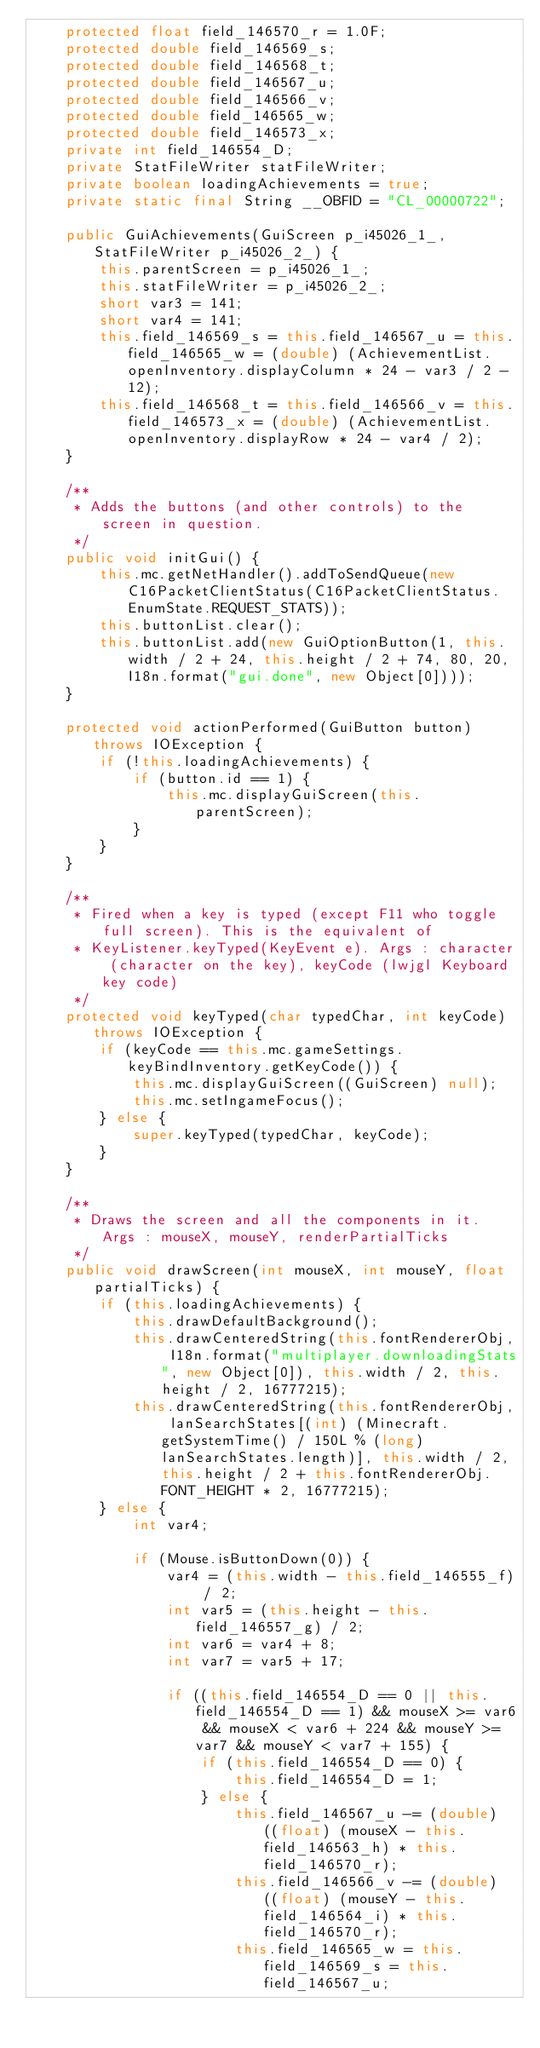Convert code to text. <code><loc_0><loc_0><loc_500><loc_500><_Java_>    protected float field_146570_r = 1.0F;
    protected double field_146569_s;
    protected double field_146568_t;
    protected double field_146567_u;
    protected double field_146566_v;
    protected double field_146565_w;
    protected double field_146573_x;
    private int field_146554_D;
    private StatFileWriter statFileWriter;
    private boolean loadingAchievements = true;
    private static final String __OBFID = "CL_00000722";

    public GuiAchievements(GuiScreen p_i45026_1_, StatFileWriter p_i45026_2_) {
        this.parentScreen = p_i45026_1_;
        this.statFileWriter = p_i45026_2_;
        short var3 = 141;
        short var4 = 141;
        this.field_146569_s = this.field_146567_u = this.field_146565_w = (double) (AchievementList.openInventory.displayColumn * 24 - var3 / 2 - 12);
        this.field_146568_t = this.field_146566_v = this.field_146573_x = (double) (AchievementList.openInventory.displayRow * 24 - var4 / 2);
    }

    /**
     * Adds the buttons (and other controls) to the screen in question.
     */
    public void initGui() {
        this.mc.getNetHandler().addToSendQueue(new C16PacketClientStatus(C16PacketClientStatus.EnumState.REQUEST_STATS));
        this.buttonList.clear();
        this.buttonList.add(new GuiOptionButton(1, this.width / 2 + 24, this.height / 2 + 74, 80, 20, I18n.format("gui.done", new Object[0])));
    }

    protected void actionPerformed(GuiButton button) throws IOException {
        if (!this.loadingAchievements) {
            if (button.id == 1) {
                this.mc.displayGuiScreen(this.parentScreen);
            }
        }
    }

    /**
     * Fired when a key is typed (except F11 who toggle full screen). This is the equivalent of
     * KeyListener.keyTyped(KeyEvent e). Args : character (character on the key), keyCode (lwjgl Keyboard key code)
     */
    protected void keyTyped(char typedChar, int keyCode) throws IOException {
        if (keyCode == this.mc.gameSettings.keyBindInventory.getKeyCode()) {
            this.mc.displayGuiScreen((GuiScreen) null);
            this.mc.setIngameFocus();
        } else {
            super.keyTyped(typedChar, keyCode);
        }
    }

    /**
     * Draws the screen and all the components in it. Args : mouseX, mouseY, renderPartialTicks
     */
    public void drawScreen(int mouseX, int mouseY, float partialTicks) {
        if (this.loadingAchievements) {
            this.drawDefaultBackground();
            this.drawCenteredString(this.fontRendererObj, I18n.format("multiplayer.downloadingStats", new Object[0]), this.width / 2, this.height / 2, 16777215);
            this.drawCenteredString(this.fontRendererObj, lanSearchStates[(int) (Minecraft.getSystemTime() / 150L % (long) lanSearchStates.length)], this.width / 2, this.height / 2 + this.fontRendererObj.FONT_HEIGHT * 2, 16777215);
        } else {
            int var4;

            if (Mouse.isButtonDown(0)) {
                var4 = (this.width - this.field_146555_f) / 2;
                int var5 = (this.height - this.field_146557_g) / 2;
                int var6 = var4 + 8;
                int var7 = var5 + 17;

                if ((this.field_146554_D == 0 || this.field_146554_D == 1) && mouseX >= var6 && mouseX < var6 + 224 && mouseY >= var7 && mouseY < var7 + 155) {
                    if (this.field_146554_D == 0) {
                        this.field_146554_D = 1;
                    } else {
                        this.field_146567_u -= (double) ((float) (mouseX - this.field_146563_h) * this.field_146570_r);
                        this.field_146566_v -= (double) ((float) (mouseY - this.field_146564_i) * this.field_146570_r);
                        this.field_146565_w = this.field_146569_s = this.field_146567_u;</code> 